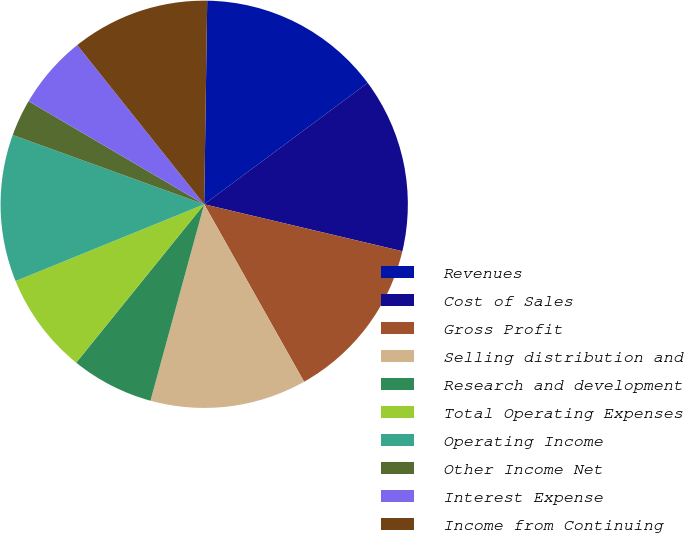Convert chart. <chart><loc_0><loc_0><loc_500><loc_500><pie_chart><fcel>Revenues<fcel>Cost of Sales<fcel>Gross Profit<fcel>Selling distribution and<fcel>Research and development<fcel>Total Operating Expenses<fcel>Operating Income<fcel>Other Income Net<fcel>Interest Expense<fcel>Income from Continuing<nl><fcel>14.6%<fcel>13.87%<fcel>13.14%<fcel>12.41%<fcel>6.57%<fcel>8.03%<fcel>11.68%<fcel>2.92%<fcel>5.84%<fcel>10.95%<nl></chart> 